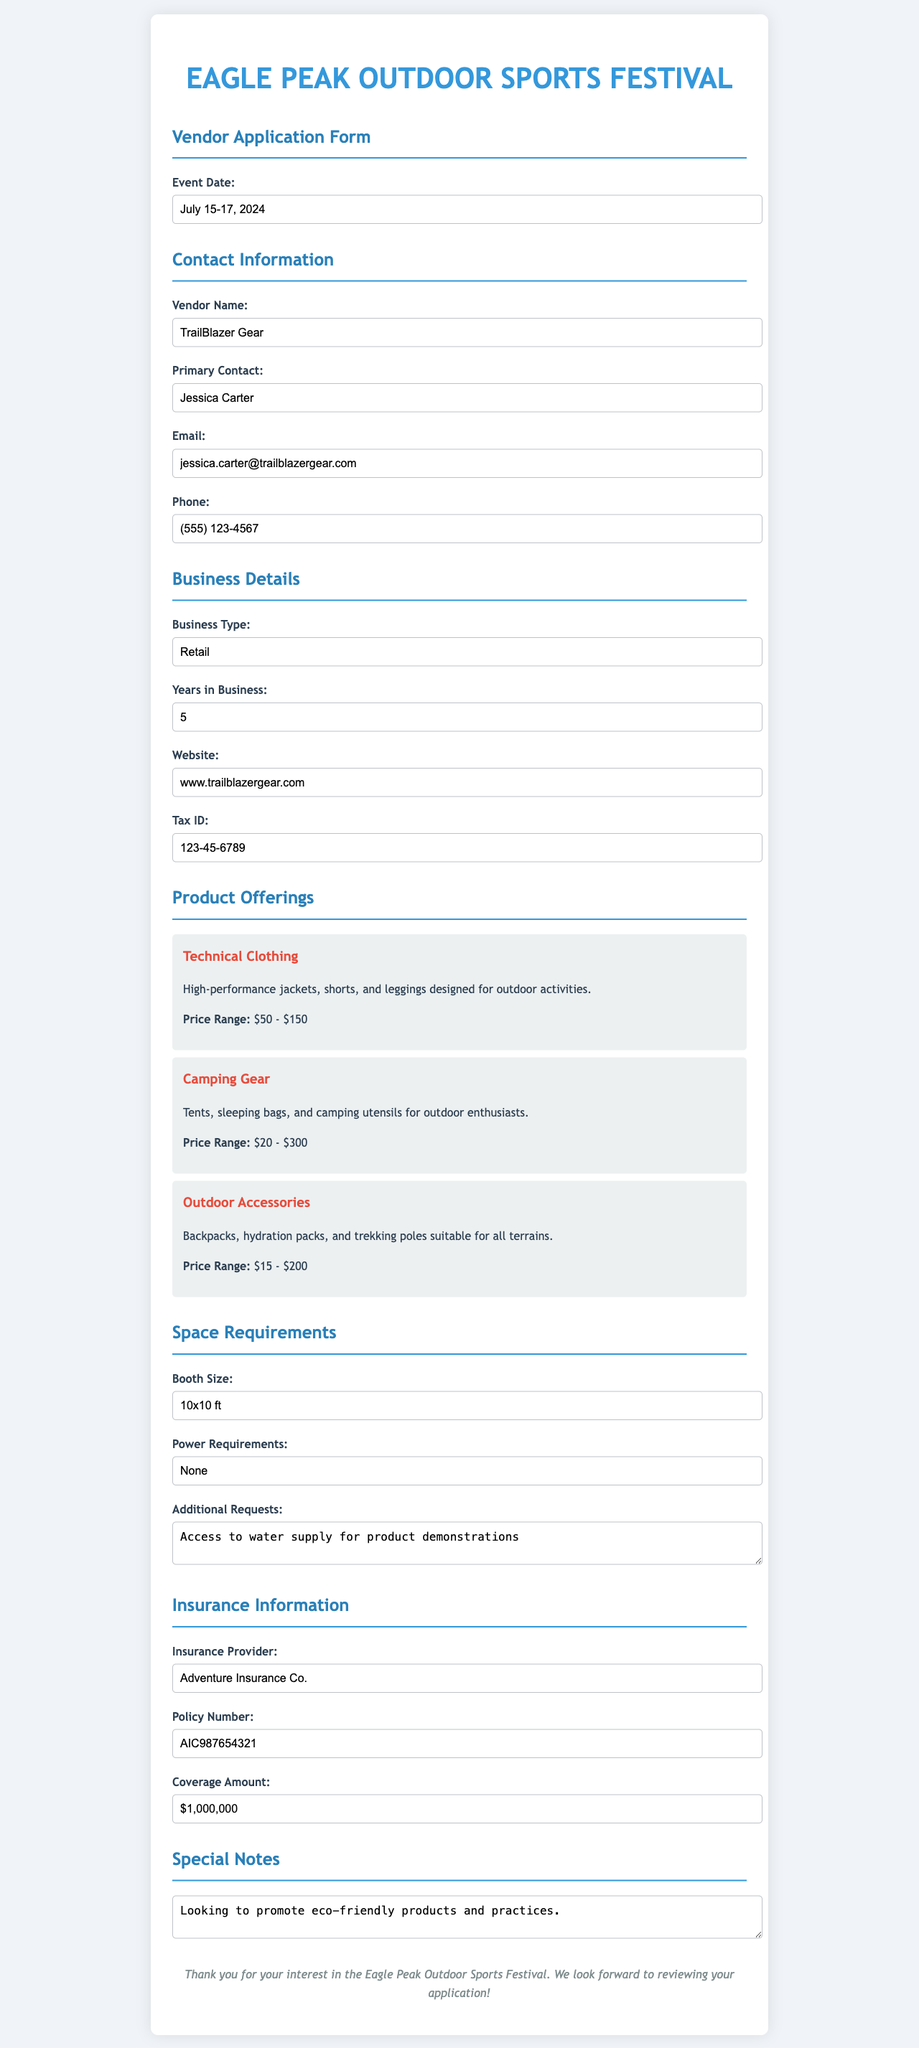what is the event date? The event date is stated clearly in the document, which is July 15-17, 2024.
Answer: July 15-17, 2024 who is the primary contact? The primary contact's name is provided in the document as Jessica Carter.
Answer: Jessica Carter what is the business type? The document specifies the business type as Retail.
Answer: Retail how many years has the vendor been in business? The document indicates the vendor has been in business for 5 years.
Answer: 5 what is the price range for camping gear? The price range for camping gear is listed in the document as $20 - $300.
Answer: $20 - $300 what are the power requirements stated by the vendor? The vendor has specified that they require no power in the document.
Answer: None what is the coverage amount of the insurance policy? The insurance coverage amount is noted in the document as $1,000,000.
Answer: $1,000,000 what additional request has the vendor made? The vendor has an additional request for access to water supply for product demonstrations.
Answer: Access to water supply for product demonstrations what specific promotion does the vendor mention in special notes? The vendor mentions promoting eco-friendly products and practices in the special notes section.
Answer: eco-friendly products and practices 